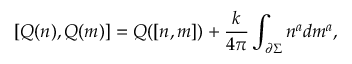<formula> <loc_0><loc_0><loc_500><loc_500>[ Q ( n ) , Q ( m ) ] = Q ( [ n , m ] ) + { \frac { k } 4 \pi } } \int _ { { \partial } \Sigma } n ^ { a } d m ^ { a } ,</formula> 